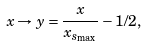<formula> <loc_0><loc_0><loc_500><loc_500>x \rightarrow y = \frac { x } { x _ { s _ { \max } } } - 1 / 2 ,</formula> 